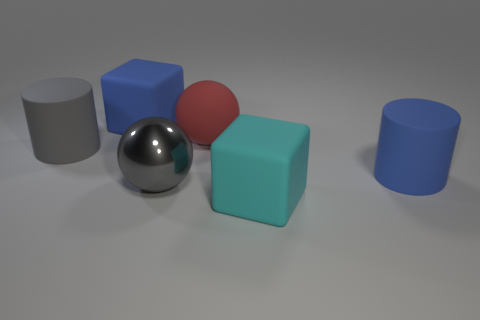What material is the thing that is both to the left of the red matte ball and on the right side of the large blue rubber block?
Offer a very short reply. Metal. What number of matte cylinders are to the left of the large red ball?
Ensure brevity in your answer.  1. How many small yellow cylinders are there?
Your answer should be very brief. 0. There is a big rubber cube to the right of the big matte cube that is on the left side of the big shiny sphere; are there any big spheres to the right of it?
Your response must be concise. No. There is a large blue object that is the same shape as the cyan matte object; what is it made of?
Provide a succinct answer. Rubber. There is a big block behind the large blue cylinder; what color is it?
Keep it short and to the point. Blue. There is a red object; is its size the same as the gray rubber cylinder that is left of the large cyan matte block?
Your response must be concise. Yes. There is a large rubber thing that is left of the blue rubber cube that is behind the big matte cube right of the big red rubber ball; what is its color?
Ensure brevity in your answer.  Gray. Are the big cylinder that is to the right of the big cyan rubber thing and the large cyan object made of the same material?
Offer a terse response. Yes. How many other objects are the same material as the big red sphere?
Make the answer very short. 4. 